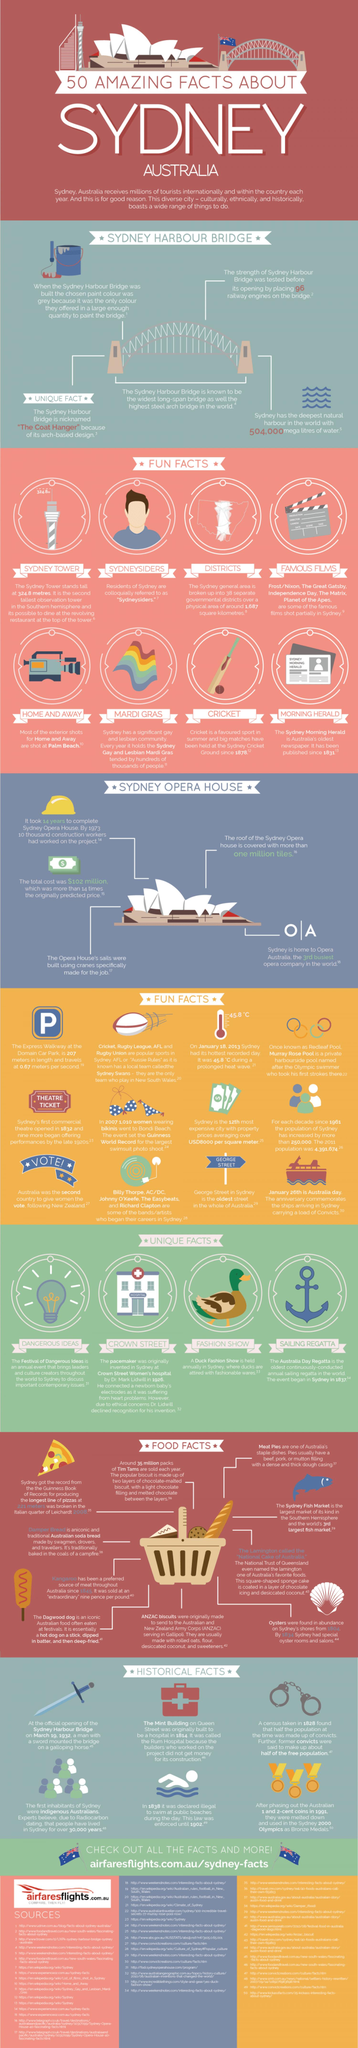Mention a couple of crucial points in this snapshot. Opera Australia is an organization known as O, which is a well-known opera company in Australia that provides various opera-related performances and events for the public to enjoy. The largest swimsuit photo shoot took place in 2007. The anchor is showing a unique fact about a sailing regatta. The strength of the Sydney Harbour Bridge was tested using 96 railway engines. The nickname of Sydney Harbour Bridge is "the coat hanger. 